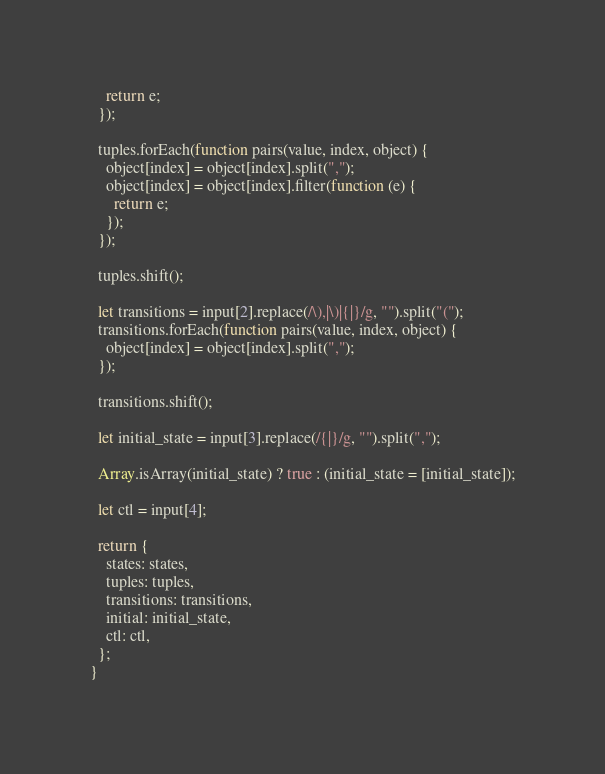<code> <loc_0><loc_0><loc_500><loc_500><_JavaScript_>    return e;
  });

  tuples.forEach(function pairs(value, index, object) {
    object[index] = object[index].split(",");
    object[index] = object[index].filter(function (e) {
      return e;
    });
  });

  tuples.shift();

  let transitions = input[2].replace(/\),|\)|{|}/g, "").split("(");
  transitions.forEach(function pairs(value, index, object) {
    object[index] = object[index].split(",");
  });

  transitions.shift();

  let initial_state = input[3].replace(/{|}/g, "").split(",");

  Array.isArray(initial_state) ? true : (initial_state = [initial_state]);

  let ctl = input[4];

  return {
    states: states,
    tuples: tuples,
    transitions: transitions,
    initial: initial_state,
    ctl: ctl,
  };
}
</code> 